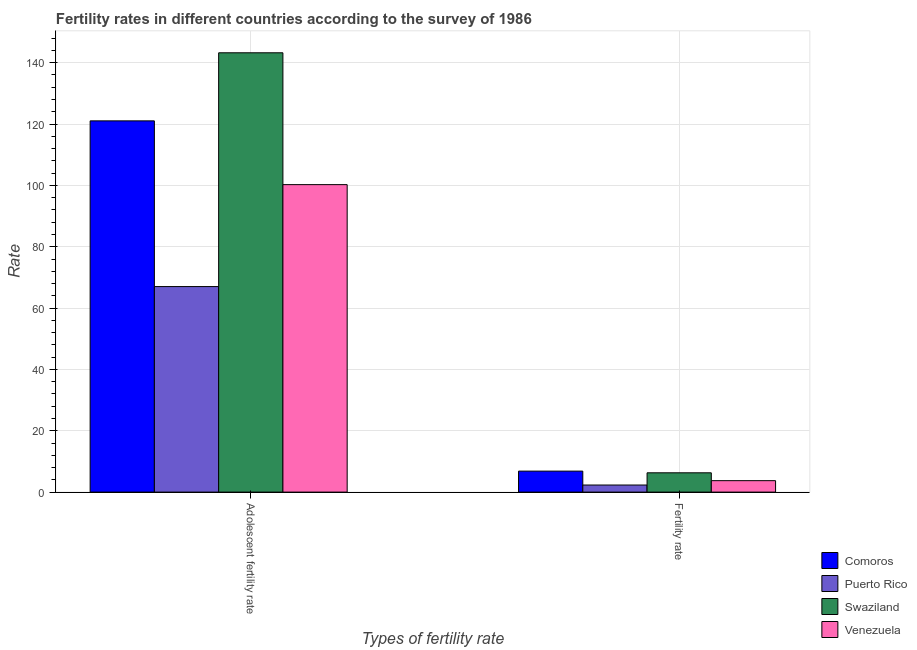How many different coloured bars are there?
Your response must be concise. 4. How many bars are there on the 2nd tick from the left?
Keep it short and to the point. 4. How many bars are there on the 2nd tick from the right?
Your answer should be compact. 4. What is the label of the 2nd group of bars from the left?
Provide a succinct answer. Fertility rate. What is the fertility rate in Venezuela?
Offer a terse response. 3.73. Across all countries, what is the maximum adolescent fertility rate?
Make the answer very short. 143.23. Across all countries, what is the minimum adolescent fertility rate?
Offer a terse response. 67.01. In which country was the adolescent fertility rate maximum?
Make the answer very short. Swaziland. In which country was the adolescent fertility rate minimum?
Keep it short and to the point. Puerto Rico. What is the total fertility rate in the graph?
Your answer should be compact. 19.17. What is the difference between the fertility rate in Puerto Rico and that in Comoros?
Ensure brevity in your answer.  -4.53. What is the difference between the adolescent fertility rate in Venezuela and the fertility rate in Puerto Rico?
Ensure brevity in your answer.  97.94. What is the average fertility rate per country?
Make the answer very short. 4.79. What is the difference between the adolescent fertility rate and fertility rate in Venezuela?
Your answer should be very brief. 96.52. What is the ratio of the fertility rate in Puerto Rico to that in Comoros?
Provide a short and direct response. 0.34. In how many countries, is the fertility rate greater than the average fertility rate taken over all countries?
Give a very brief answer. 2. What does the 1st bar from the left in Adolescent fertility rate represents?
Offer a very short reply. Comoros. What does the 1st bar from the right in Adolescent fertility rate represents?
Offer a very short reply. Venezuela. How many bars are there?
Give a very brief answer. 8. Are all the bars in the graph horizontal?
Provide a succinct answer. No. How many countries are there in the graph?
Offer a terse response. 4. Does the graph contain any zero values?
Your answer should be compact. No. What is the title of the graph?
Ensure brevity in your answer.  Fertility rates in different countries according to the survey of 1986. Does "Trinidad and Tobago" appear as one of the legend labels in the graph?
Make the answer very short. No. What is the label or title of the X-axis?
Offer a terse response. Types of fertility rate. What is the label or title of the Y-axis?
Provide a succinct answer. Rate. What is the Rate of Comoros in Adolescent fertility rate?
Make the answer very short. 121.04. What is the Rate in Puerto Rico in Adolescent fertility rate?
Your answer should be compact. 67.01. What is the Rate in Swaziland in Adolescent fertility rate?
Provide a succinct answer. 143.23. What is the Rate of Venezuela in Adolescent fertility rate?
Provide a succinct answer. 100.25. What is the Rate in Comoros in Fertility rate?
Offer a very short reply. 6.84. What is the Rate in Puerto Rico in Fertility rate?
Provide a short and direct response. 2.31. What is the Rate of Swaziland in Fertility rate?
Provide a succinct answer. 6.29. What is the Rate of Venezuela in Fertility rate?
Ensure brevity in your answer.  3.73. Across all Types of fertility rate, what is the maximum Rate of Comoros?
Ensure brevity in your answer.  121.04. Across all Types of fertility rate, what is the maximum Rate in Puerto Rico?
Your answer should be very brief. 67.01. Across all Types of fertility rate, what is the maximum Rate in Swaziland?
Keep it short and to the point. 143.23. Across all Types of fertility rate, what is the maximum Rate in Venezuela?
Offer a terse response. 100.25. Across all Types of fertility rate, what is the minimum Rate of Comoros?
Your answer should be compact. 6.84. Across all Types of fertility rate, what is the minimum Rate in Puerto Rico?
Ensure brevity in your answer.  2.31. Across all Types of fertility rate, what is the minimum Rate of Swaziland?
Give a very brief answer. 6.29. Across all Types of fertility rate, what is the minimum Rate of Venezuela?
Ensure brevity in your answer.  3.73. What is the total Rate in Comoros in the graph?
Ensure brevity in your answer.  127.88. What is the total Rate in Puerto Rico in the graph?
Your response must be concise. 69.32. What is the total Rate of Swaziland in the graph?
Offer a very short reply. 149.52. What is the total Rate in Venezuela in the graph?
Your answer should be very brief. 103.98. What is the difference between the Rate in Comoros in Adolescent fertility rate and that in Fertility rate?
Your answer should be very brief. 114.2. What is the difference between the Rate of Puerto Rico in Adolescent fertility rate and that in Fertility rate?
Keep it short and to the point. 64.7. What is the difference between the Rate of Swaziland in Adolescent fertility rate and that in Fertility rate?
Keep it short and to the point. 136.94. What is the difference between the Rate of Venezuela in Adolescent fertility rate and that in Fertility rate?
Your response must be concise. 96.52. What is the difference between the Rate in Comoros in Adolescent fertility rate and the Rate in Puerto Rico in Fertility rate?
Offer a terse response. 118.73. What is the difference between the Rate of Comoros in Adolescent fertility rate and the Rate of Swaziland in Fertility rate?
Provide a succinct answer. 114.75. What is the difference between the Rate of Comoros in Adolescent fertility rate and the Rate of Venezuela in Fertility rate?
Offer a very short reply. 117.31. What is the difference between the Rate of Puerto Rico in Adolescent fertility rate and the Rate of Swaziland in Fertility rate?
Offer a terse response. 60.72. What is the difference between the Rate in Puerto Rico in Adolescent fertility rate and the Rate in Venezuela in Fertility rate?
Offer a terse response. 63.28. What is the difference between the Rate of Swaziland in Adolescent fertility rate and the Rate of Venezuela in Fertility rate?
Make the answer very short. 139.5. What is the average Rate of Comoros per Types of fertility rate?
Provide a succinct answer. 63.94. What is the average Rate of Puerto Rico per Types of fertility rate?
Give a very brief answer. 34.66. What is the average Rate of Swaziland per Types of fertility rate?
Offer a terse response. 74.76. What is the average Rate of Venezuela per Types of fertility rate?
Your answer should be very brief. 51.99. What is the difference between the Rate of Comoros and Rate of Puerto Rico in Adolescent fertility rate?
Make the answer very short. 54.03. What is the difference between the Rate in Comoros and Rate in Swaziland in Adolescent fertility rate?
Your answer should be very brief. -22.19. What is the difference between the Rate of Comoros and Rate of Venezuela in Adolescent fertility rate?
Your answer should be very brief. 20.79. What is the difference between the Rate in Puerto Rico and Rate in Swaziland in Adolescent fertility rate?
Give a very brief answer. -76.22. What is the difference between the Rate in Puerto Rico and Rate in Venezuela in Adolescent fertility rate?
Your answer should be compact. -33.24. What is the difference between the Rate in Swaziland and Rate in Venezuela in Adolescent fertility rate?
Provide a succinct answer. 42.98. What is the difference between the Rate of Comoros and Rate of Puerto Rico in Fertility rate?
Offer a very short reply. 4.53. What is the difference between the Rate in Comoros and Rate in Swaziland in Fertility rate?
Your answer should be compact. 0.55. What is the difference between the Rate in Comoros and Rate in Venezuela in Fertility rate?
Offer a terse response. 3.11. What is the difference between the Rate in Puerto Rico and Rate in Swaziland in Fertility rate?
Keep it short and to the point. -3.98. What is the difference between the Rate of Puerto Rico and Rate of Venezuela in Fertility rate?
Your answer should be very brief. -1.42. What is the difference between the Rate in Swaziland and Rate in Venezuela in Fertility rate?
Provide a short and direct response. 2.56. What is the ratio of the Rate in Comoros in Adolescent fertility rate to that in Fertility rate?
Your answer should be compact. 17.69. What is the ratio of the Rate of Puerto Rico in Adolescent fertility rate to that in Fertility rate?
Your response must be concise. 29.03. What is the ratio of the Rate of Swaziland in Adolescent fertility rate to that in Fertility rate?
Keep it short and to the point. 22.77. What is the ratio of the Rate of Venezuela in Adolescent fertility rate to that in Fertility rate?
Your response must be concise. 26.88. What is the difference between the highest and the second highest Rate in Comoros?
Give a very brief answer. 114.2. What is the difference between the highest and the second highest Rate in Puerto Rico?
Your answer should be compact. 64.7. What is the difference between the highest and the second highest Rate in Swaziland?
Your answer should be compact. 136.94. What is the difference between the highest and the second highest Rate in Venezuela?
Your response must be concise. 96.52. What is the difference between the highest and the lowest Rate of Comoros?
Provide a short and direct response. 114.2. What is the difference between the highest and the lowest Rate in Puerto Rico?
Ensure brevity in your answer.  64.7. What is the difference between the highest and the lowest Rate in Swaziland?
Keep it short and to the point. 136.94. What is the difference between the highest and the lowest Rate of Venezuela?
Keep it short and to the point. 96.52. 